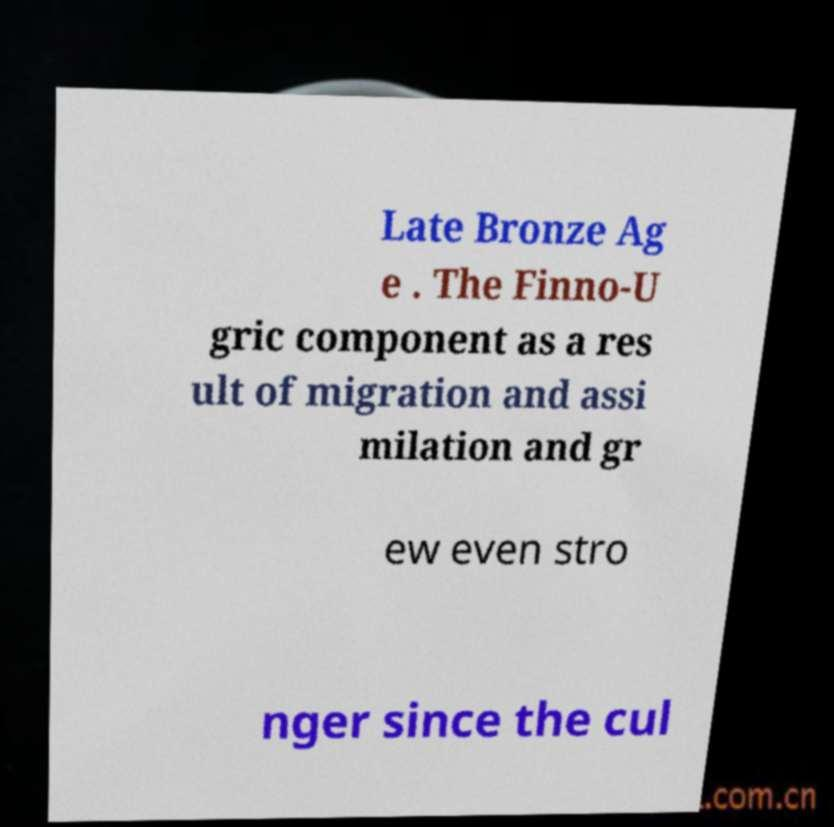What messages or text are displayed in this image? I need them in a readable, typed format. Late Bronze Ag e . The Finno-U gric component as a res ult of migration and assi milation and gr ew even stro nger since the cul 